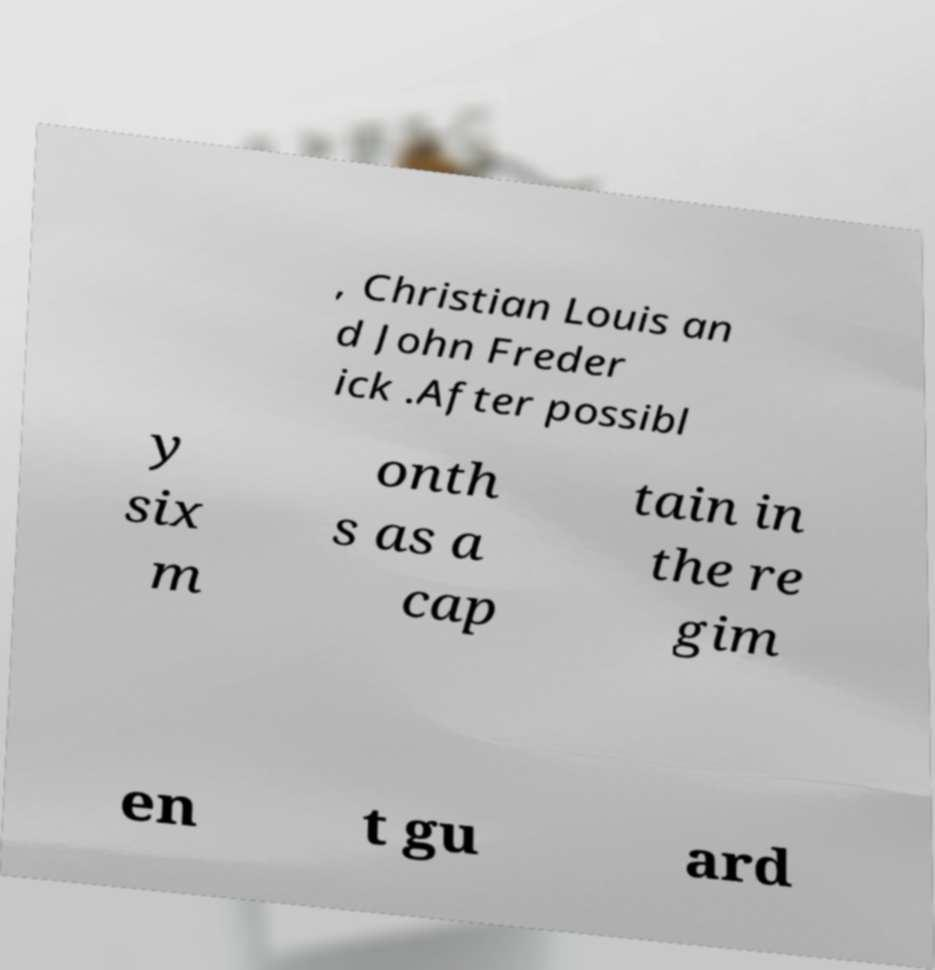Please identify and transcribe the text found in this image. , Christian Louis an d John Freder ick .After possibl y six m onth s as a cap tain in the re gim en t gu ard 